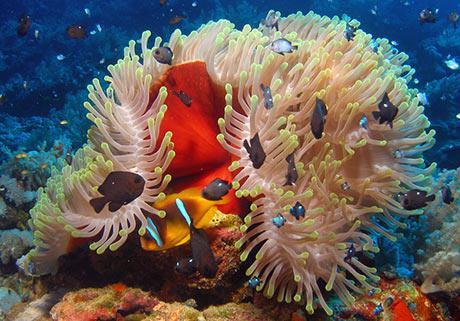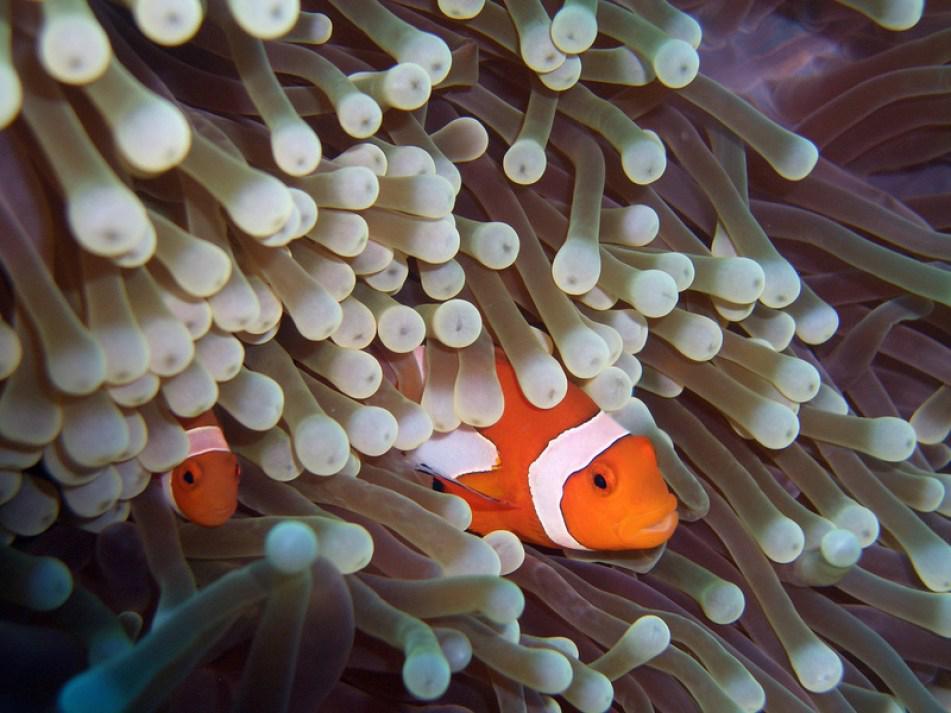The first image is the image on the left, the second image is the image on the right. Considering the images on both sides, is "There are various species of fish in one of the images." valid? Answer yes or no. Yes. 